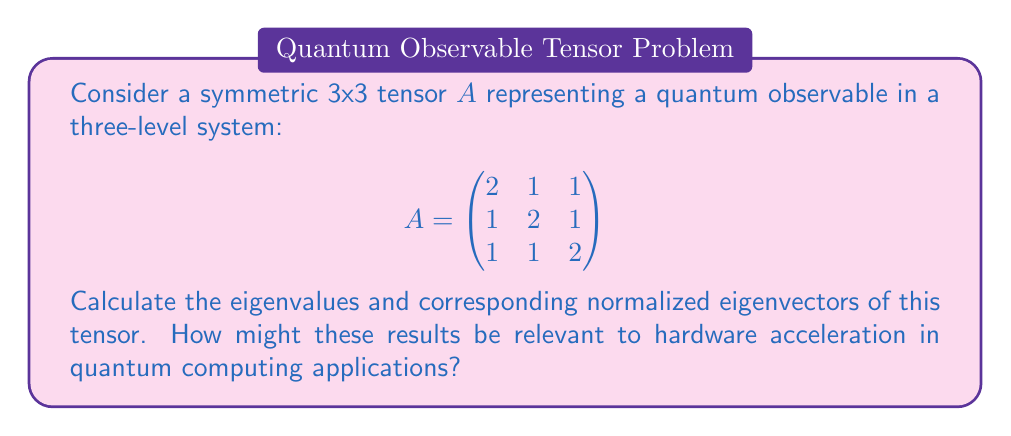What is the answer to this math problem? 1) To find the eigenvalues, we solve the characteristic equation:
   $$\det(A - \lambda I) = 0$$

2) Expanding the determinant:
   $$\begin{vmatrix}
   2-\lambda & 1 & 1 \\
   1 & 2-\lambda & 1 \\
   1 & 1 & 2-\lambda
   \end{vmatrix} = 0$$

3) This gives us:
   $$(2-\lambda)^3 + 2 - 3(2-\lambda) = 0$$
   $$-\lambda^3 + 6\lambda^2 - 12\lambda + 8 = 0$$

4) Factoring this equation:
   $$-(\lambda - 4)(\lambda - 1)^2 = 0$$

5) Therefore, the eigenvalues are:
   $$\lambda_1 = 4, \lambda_2 = \lambda_3 = 1$$

6) For $\lambda_1 = 4$, we solve $(A - 4I)v = 0$:
   $$\begin{pmatrix}
   -2 & 1 & 1 \\
   1 & -2 & 1 \\
   1 & 1 & -2
   \end{pmatrix}\begin{pmatrix}
   v_1 \\ v_2 \\ v_3
   \end{pmatrix} = \begin{pmatrix}
   0 \\ 0 \\ 0
   \end{pmatrix}$$

   This gives $v_1 = v_2 = v_3$. Normalizing, we get:
   $$v_1 = \frac{1}{\sqrt{3}}(1, 1, 1)^T$$

7) For $\lambda_2 = \lambda_3 = 1$, we solve $(A - I)v = 0$:
   $$\begin{pmatrix}
   1 & 1 & 1 \\
   1 & 1 & 1 \\
   1 & 1 & 1
   \end{pmatrix}\begin{pmatrix}
   v_1 \\ v_2 \\ v_3
   \end{pmatrix} = \begin{pmatrix}
   0 \\ 0 \\ 0
   \end{pmatrix}$$

   This gives $v_1 + v_2 + v_3 = 0$. Two orthonormal eigenvectors satisfying this are:
   $$v_2 = \frac{1}{\sqrt{2}}(1, -1, 0)^T$$
   $$v_3 = \frac{1}{\sqrt{6}}(1, 1, -2)^T$$

8) In quantum computing applications, these results are relevant to hardware acceleration as:
   a) Eigenvalues represent possible measurement outcomes of the observable.
   b) Eigenvectors represent the corresponding quantum states.
   c) Diagonalization of the tensor allows for efficient computation of matrix exponentials, crucial in quantum circuit simulations.
   d) The spectral decomposition can be used to parallelize certain quantum operations on specialized hardware.
Answer: Eigenvalues: $\lambda_1 = 4$, $\lambda_2 = \lambda_3 = 1$
Eigenvectors: $v_1 = \frac{1}{\sqrt{3}}(1, 1, 1)^T$, $v_2 = \frac{1}{\sqrt{2}}(1, -1, 0)^T$, $v_3 = \frac{1}{\sqrt{6}}(1, 1, -2)^T$ 